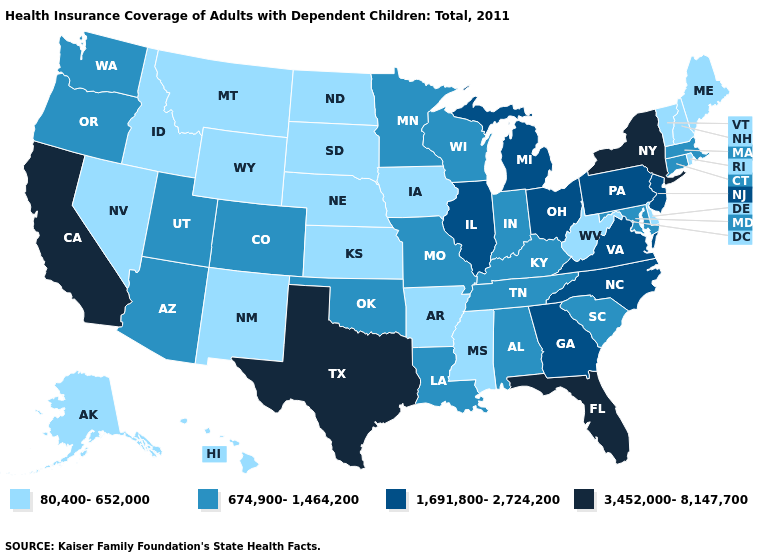What is the value of Ohio?
Answer briefly. 1,691,800-2,724,200. What is the highest value in the South ?
Be succinct. 3,452,000-8,147,700. Name the states that have a value in the range 3,452,000-8,147,700?
Answer briefly. California, Florida, New York, Texas. Which states have the lowest value in the South?
Write a very short answer. Arkansas, Delaware, Mississippi, West Virginia. Name the states that have a value in the range 674,900-1,464,200?
Answer briefly. Alabama, Arizona, Colorado, Connecticut, Indiana, Kentucky, Louisiana, Maryland, Massachusetts, Minnesota, Missouri, Oklahoma, Oregon, South Carolina, Tennessee, Utah, Washington, Wisconsin. Among the states that border Utah , which have the lowest value?
Quick response, please. Idaho, Nevada, New Mexico, Wyoming. Does New Mexico have a lower value than New York?
Short answer required. Yes. What is the value of South Carolina?
Write a very short answer. 674,900-1,464,200. Does the first symbol in the legend represent the smallest category?
Concise answer only. Yes. Does the first symbol in the legend represent the smallest category?
Give a very brief answer. Yes. Name the states that have a value in the range 1,691,800-2,724,200?
Short answer required. Georgia, Illinois, Michigan, New Jersey, North Carolina, Ohio, Pennsylvania, Virginia. What is the highest value in the West ?
Keep it brief. 3,452,000-8,147,700. What is the highest value in states that border Georgia?
Concise answer only. 3,452,000-8,147,700. How many symbols are there in the legend?
Answer briefly. 4. Name the states that have a value in the range 1,691,800-2,724,200?
Be succinct. Georgia, Illinois, Michigan, New Jersey, North Carolina, Ohio, Pennsylvania, Virginia. 